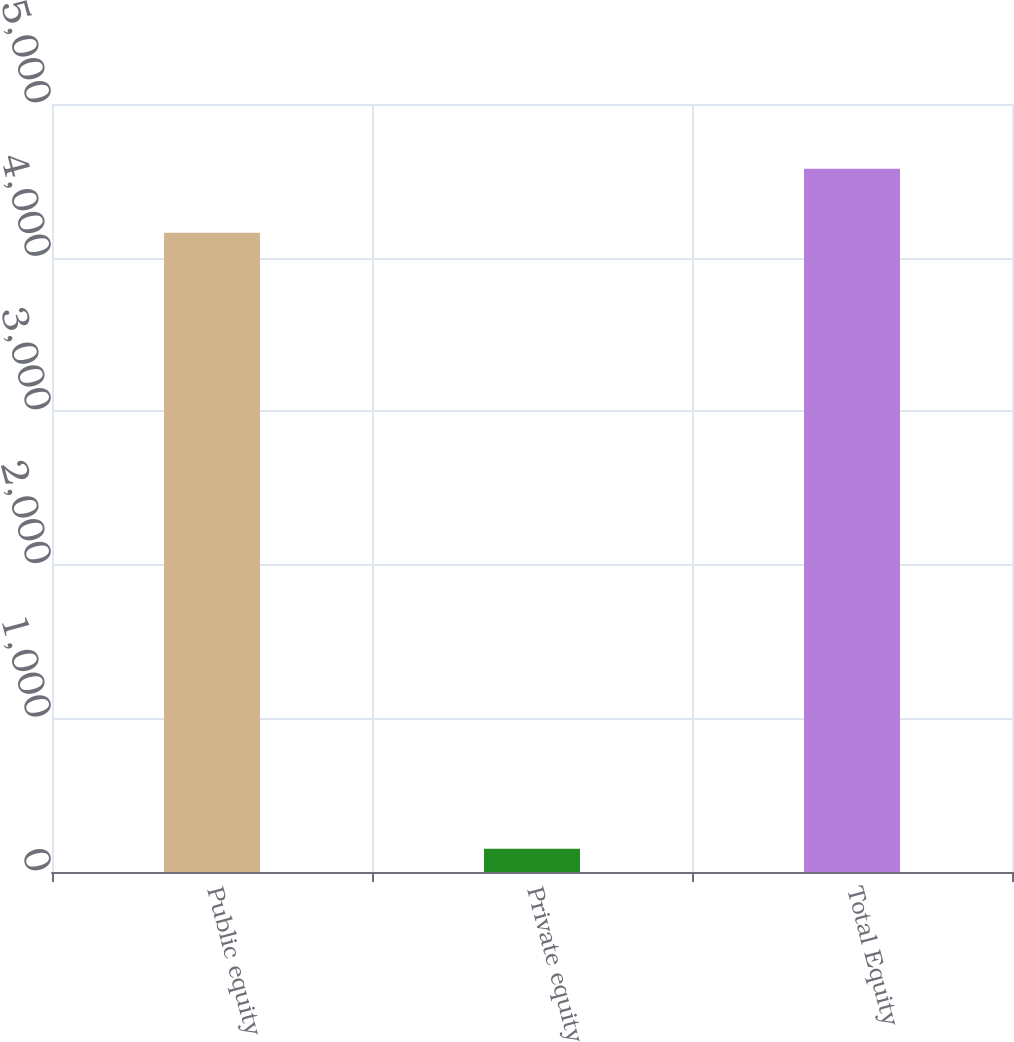<chart> <loc_0><loc_0><loc_500><loc_500><bar_chart><fcel>Public equity<fcel>Private equity<fcel>Total Equity<nl><fcel>4162<fcel>152<fcel>4578.2<nl></chart> 